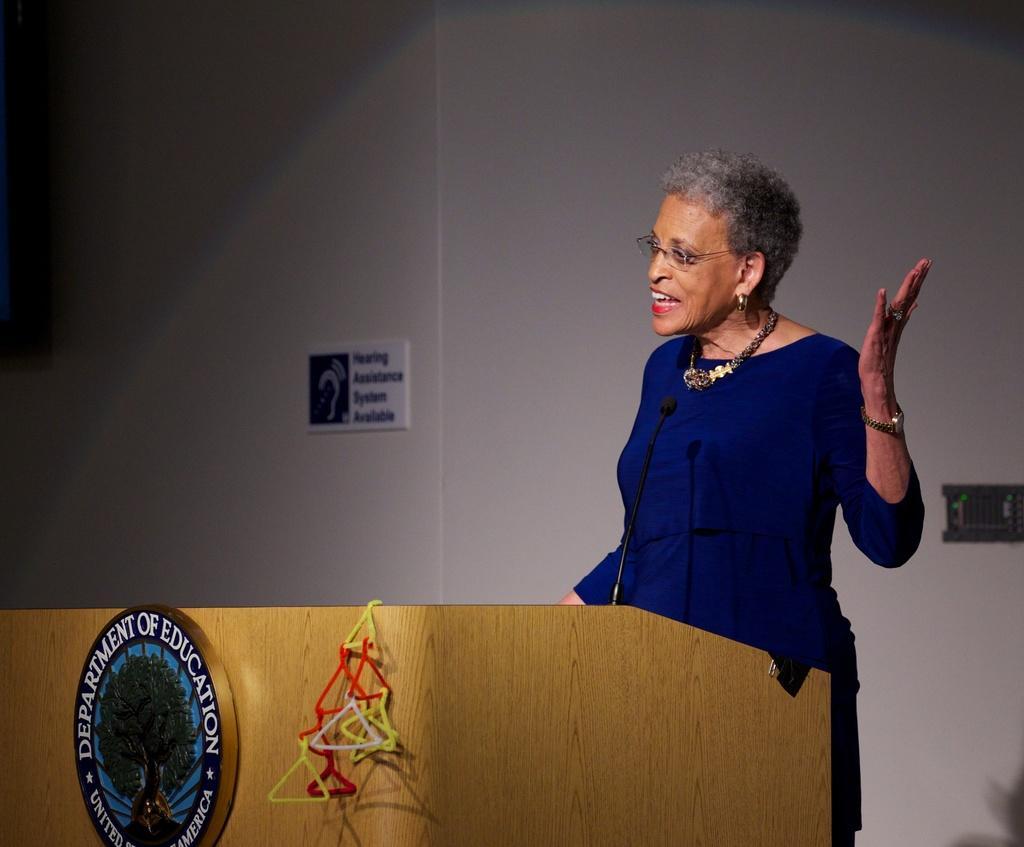Describe this image in one or two sentences. In this image, we can see a person wearing clothes and standing in front of the podium. There is a board in the middle of the image. In the background, we can see a wall. 